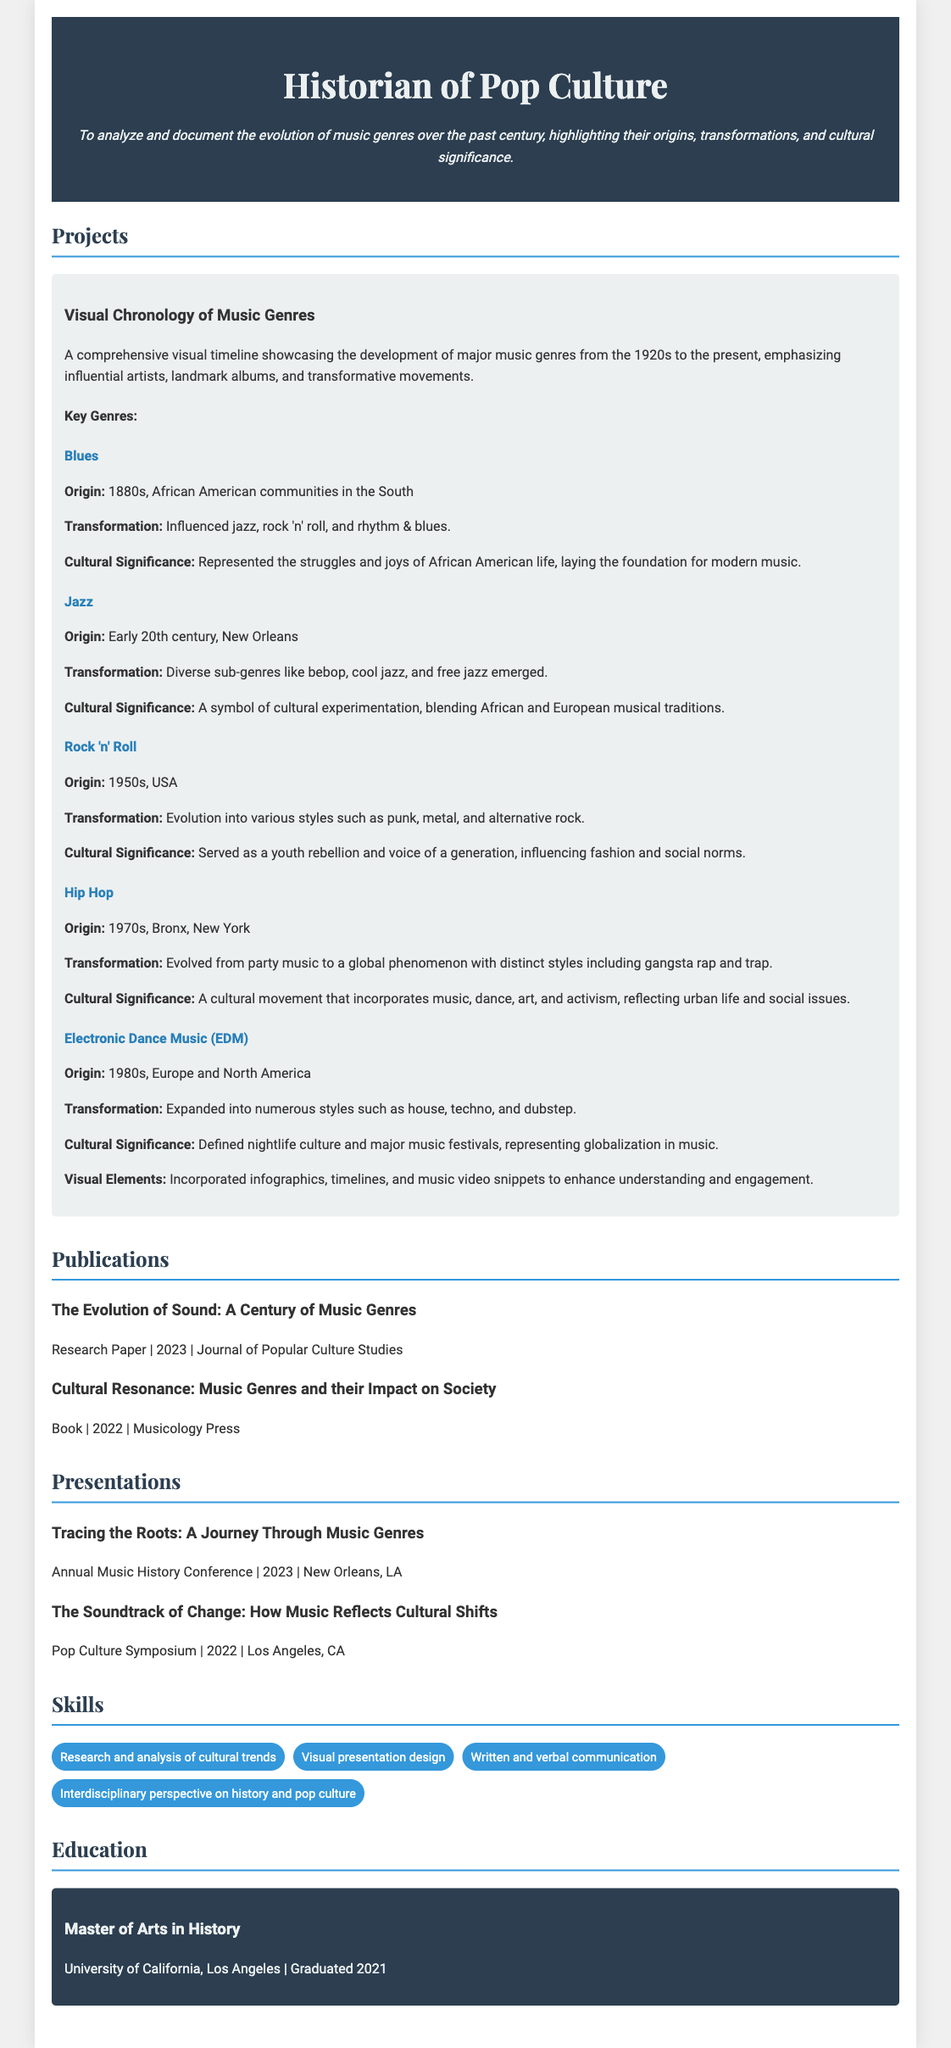what is the title of the visual chronology project? The title is clearly stated in the document under "Projects."
Answer: Visual Chronology of Music Genres who is the author of the publication titled "Cultural Resonance: Music Genres and their Impact on Society"? The author is not specified in the document; the title of the publication is provided instead.
Answer: Musicology Press in what year was the research paper "The Evolution of Sound: A Century of Music Genres" published? The publication year is mentioned directly in the document.
Answer: 2023 which music genre originated in the 1880s? The origin year is mentioned in the description of the music genre section.
Answer: Blues how many major music genres are discussed in the visual chronology project? The genres are listed under key genres in the project section of the document.
Answer: Five which music genre is associated with the Bronx, New York? The origin of this genre is specified in the document under its transformation.
Answer: Hip Hop what was the primary cultural significance of the rock 'n' roll genre? The document describes its cultural significance in the context of youth rebellion and social influence.
Answer: Served as a youth rebellion and voice of a generation which university did the historian attend for their Master's degree? The education section of the document provides the name of the university attended.
Answer: University of California, Los Angeles 